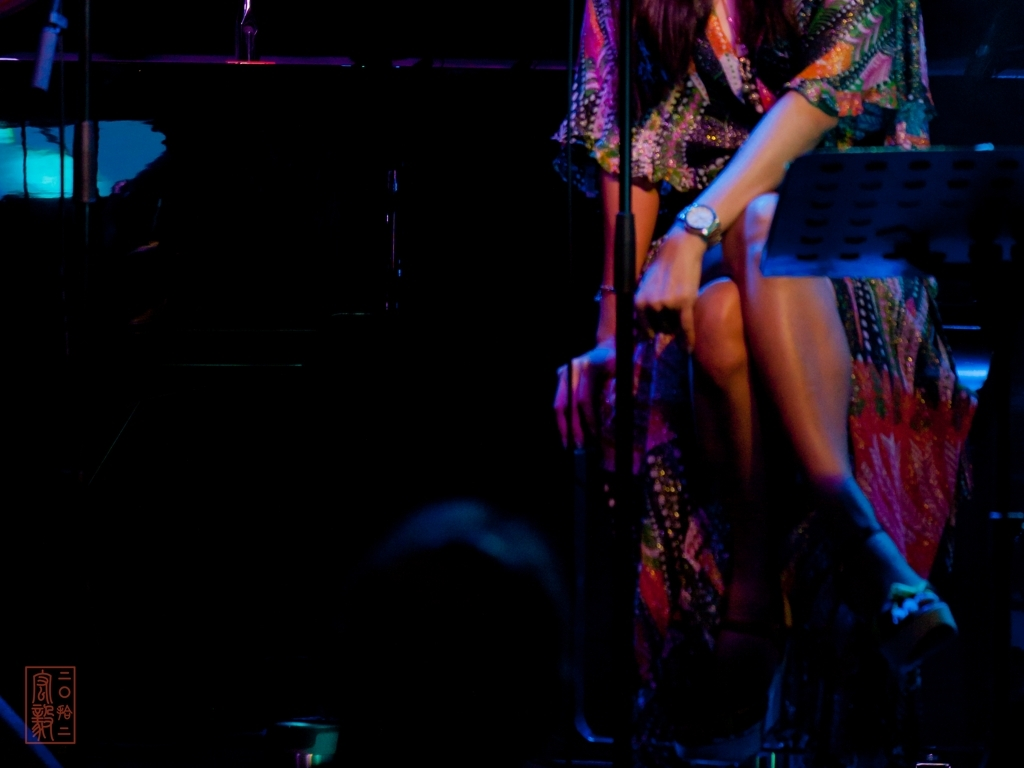Is the brightness of the image dim?
A. Yes
B. No
Answer with the option's letter from the given choices directly.
 A. 